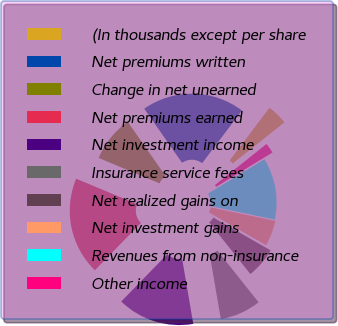<chart> <loc_0><loc_0><loc_500><loc_500><pie_chart><fcel>(In thousands except per share<fcel>Net premiums written<fcel>Change in net unearned<fcel>Net premiums earned<fcel>Net investment income<fcel>Insurance service fees<fcel>Net realized gains on<fcel>Net investment gains<fcel>Revenues from non-insurance<fcel>Other income<nl><fcel>4.0%<fcel>20.0%<fcel>9.0%<fcel>19.0%<fcel>15.0%<fcel>8.0%<fcel>6.0%<fcel>5.0%<fcel>12.0%<fcel>2.0%<nl></chart> 